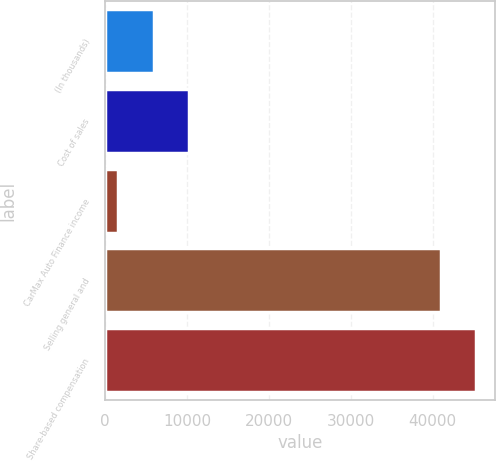<chart> <loc_0><loc_0><loc_500><loc_500><bar_chart><fcel>(In thousands)<fcel>Cost of sales<fcel>CarMax Auto Finance income<fcel>Selling general and<fcel>Share-based compensation<nl><fcel>5910.7<fcel>10218.4<fcel>1603<fcel>40996<fcel>45303.7<nl></chart> 